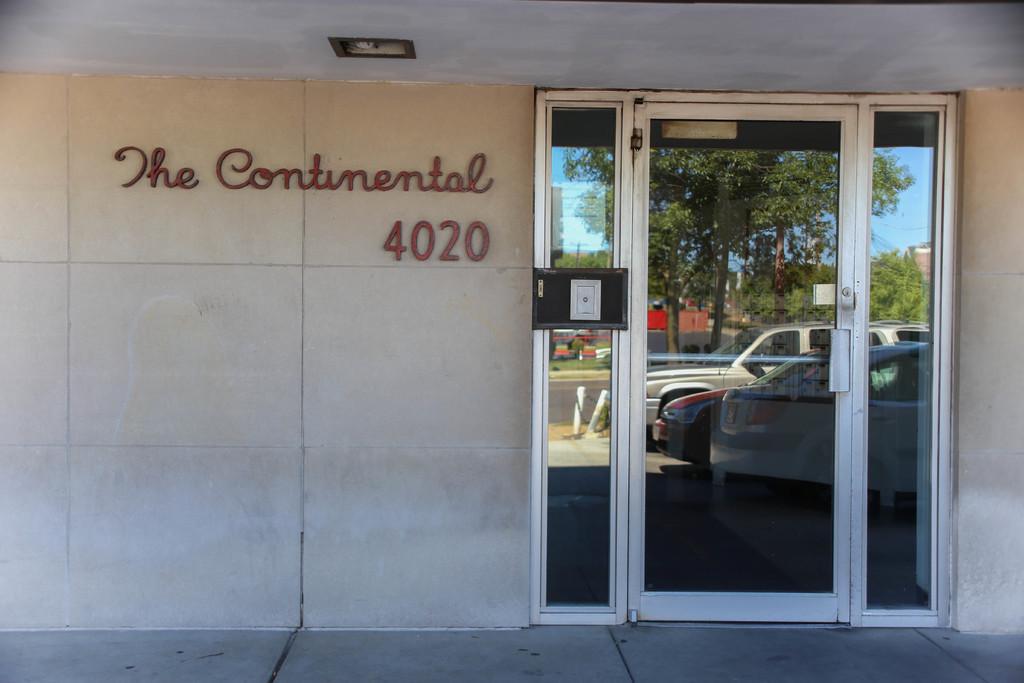Can you describe this image briefly? In this picture we can see a wall and a glass door in the front, we can see reflection of cars, trees and the sky on this glass, there is some text on the wall. 